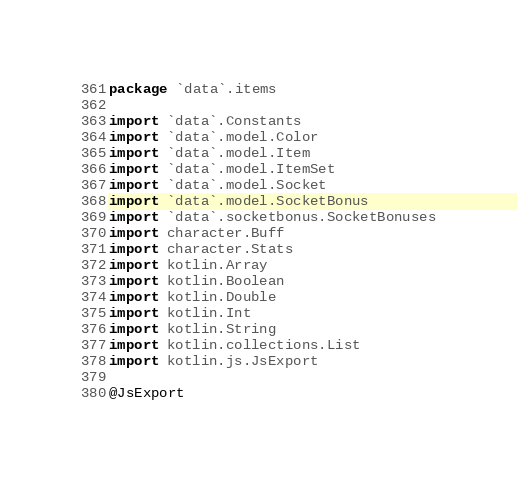Convert code to text. <code><loc_0><loc_0><loc_500><loc_500><_Kotlin_>package `data`.items

import `data`.Constants
import `data`.model.Color
import `data`.model.Item
import `data`.model.ItemSet
import `data`.model.Socket
import `data`.model.SocketBonus
import `data`.socketbonus.SocketBonuses
import character.Buff
import character.Stats
import kotlin.Array
import kotlin.Boolean
import kotlin.Double
import kotlin.Int
import kotlin.String
import kotlin.collections.List
import kotlin.js.JsExport

@JsExport</code> 